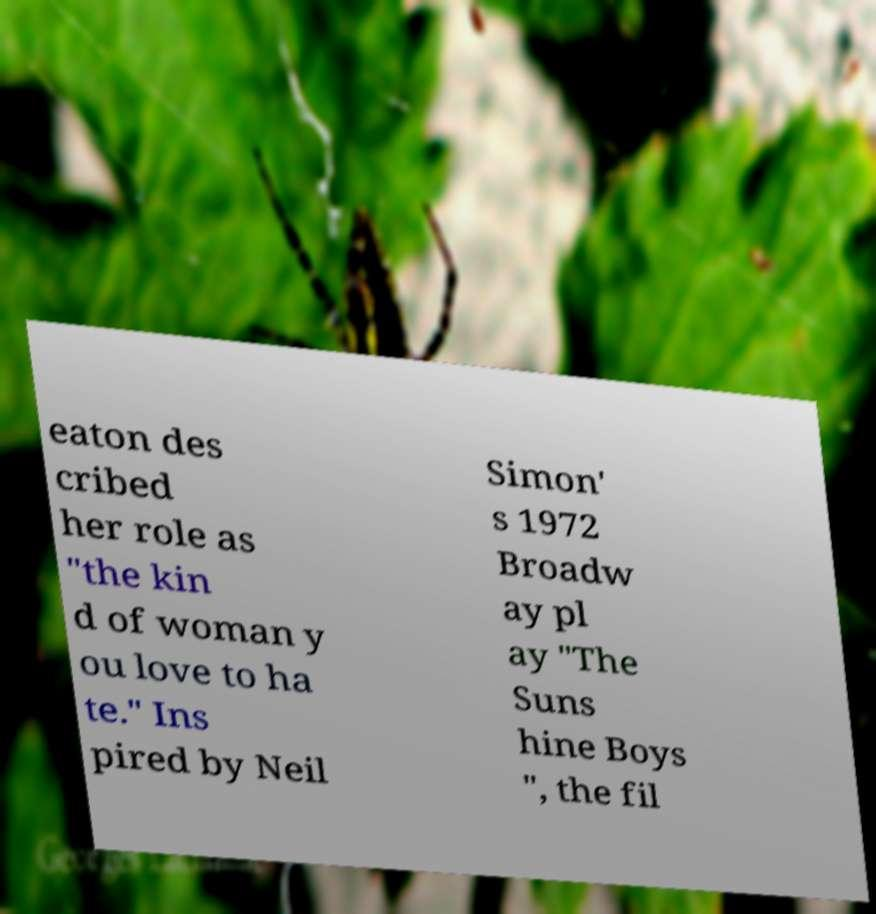Could you assist in decoding the text presented in this image and type it out clearly? eaton des cribed her role as "the kin d of woman y ou love to ha te." Ins pired by Neil Simon' s 1972 Broadw ay pl ay "The Suns hine Boys ", the fil 